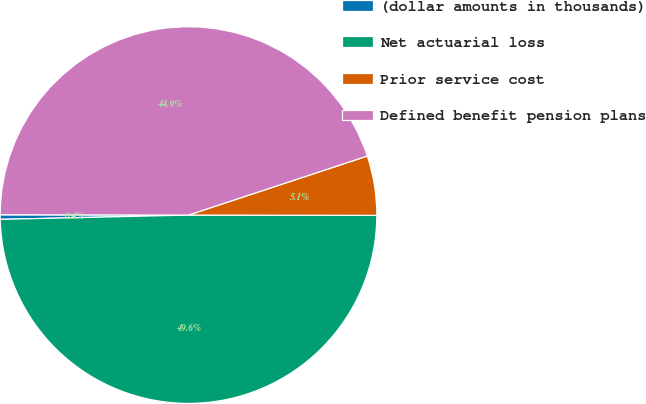<chart> <loc_0><loc_0><loc_500><loc_500><pie_chart><fcel>(dollar amounts in thousands)<fcel>Net actuarial loss<fcel>Prior service cost<fcel>Defined benefit pension plans<nl><fcel>0.39%<fcel>49.61%<fcel>5.1%<fcel>44.9%<nl></chart> 